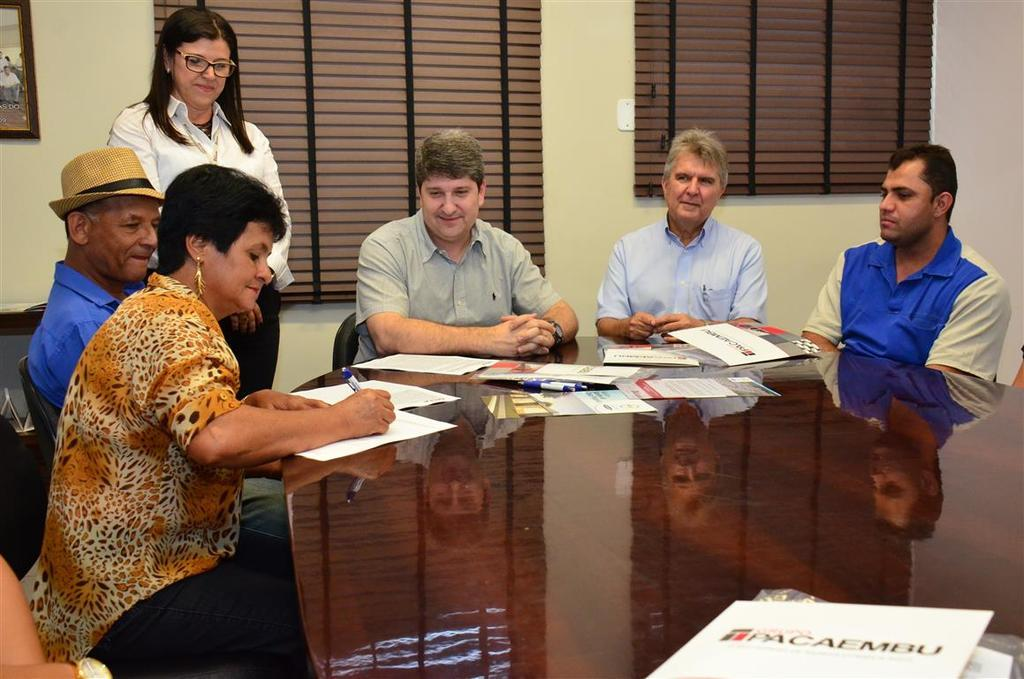How many people are in the image? There are five persons in the image. What are the persons doing in the image? The persons are sitting on chairs. What can be seen behind the chairs in the image? There is a wall behind the chairs. What type of event is taking place in the image? There is no indication of an event taking place in the image; it simply shows five persons sitting on chairs. Can you see an airplane in the image? No, there is no airplane present in the image. 